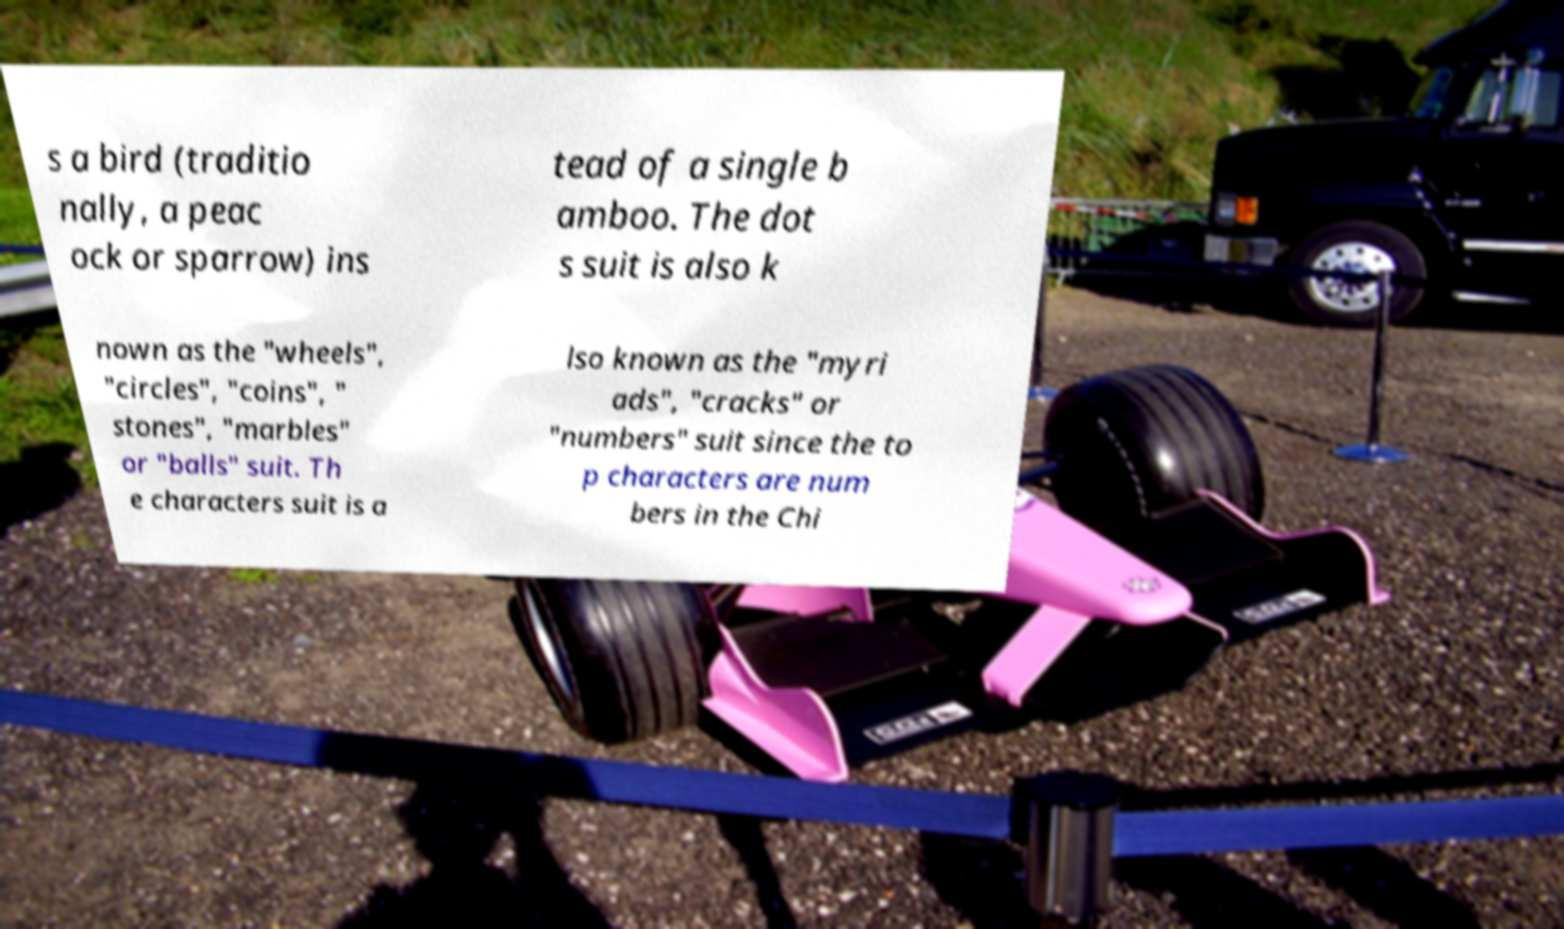What messages or text are displayed in this image? I need them in a readable, typed format. s a bird (traditio nally, a peac ock or sparrow) ins tead of a single b amboo. The dot s suit is also k nown as the "wheels", "circles", "coins", " stones", "marbles" or "balls" suit. Th e characters suit is a lso known as the "myri ads", "cracks" or "numbers" suit since the to p characters are num bers in the Chi 